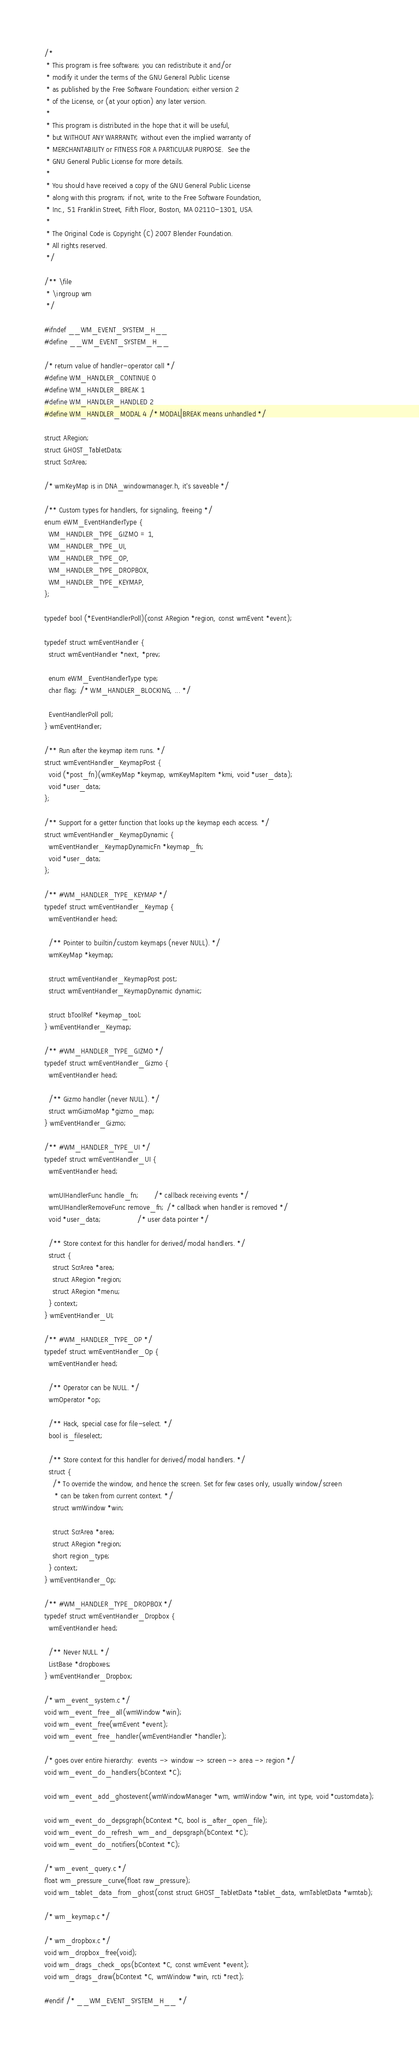<code> <loc_0><loc_0><loc_500><loc_500><_C_>/*
 * This program is free software; you can redistribute it and/or
 * modify it under the terms of the GNU General Public License
 * as published by the Free Software Foundation; either version 2
 * of the License, or (at your option) any later version.
 *
 * This program is distributed in the hope that it will be useful,
 * but WITHOUT ANY WARRANTY; without even the implied warranty of
 * MERCHANTABILITY or FITNESS FOR A PARTICULAR PURPOSE.  See the
 * GNU General Public License for more details.
 *
 * You should have received a copy of the GNU General Public License
 * along with this program; if not, write to the Free Software Foundation,
 * Inc., 51 Franklin Street, Fifth Floor, Boston, MA 02110-1301, USA.
 *
 * The Original Code is Copyright (C) 2007 Blender Foundation.
 * All rights reserved.
 */

/** \file
 * \ingroup wm
 */

#ifndef __WM_EVENT_SYSTEM_H__
#define __WM_EVENT_SYSTEM_H__

/* return value of handler-operator call */
#define WM_HANDLER_CONTINUE 0
#define WM_HANDLER_BREAK 1
#define WM_HANDLER_HANDLED 2
#define WM_HANDLER_MODAL 4 /* MODAL|BREAK means unhandled */

struct ARegion;
struct GHOST_TabletData;
struct ScrArea;

/* wmKeyMap is in DNA_windowmanager.h, it's saveable */

/** Custom types for handlers, for signaling, freeing */
enum eWM_EventHandlerType {
  WM_HANDLER_TYPE_GIZMO = 1,
  WM_HANDLER_TYPE_UI,
  WM_HANDLER_TYPE_OP,
  WM_HANDLER_TYPE_DROPBOX,
  WM_HANDLER_TYPE_KEYMAP,
};

typedef bool (*EventHandlerPoll)(const ARegion *region, const wmEvent *event);

typedef struct wmEventHandler {
  struct wmEventHandler *next, *prev;

  enum eWM_EventHandlerType type;
  char flag; /* WM_HANDLER_BLOCKING, ... */

  EventHandlerPoll poll;
} wmEventHandler;

/** Run after the keymap item runs. */
struct wmEventHandler_KeymapPost {
  void (*post_fn)(wmKeyMap *keymap, wmKeyMapItem *kmi, void *user_data);
  void *user_data;
};

/** Support for a getter function that looks up the keymap each access. */
struct wmEventHandler_KeymapDynamic {
  wmEventHandler_KeymapDynamicFn *keymap_fn;
  void *user_data;
};

/** #WM_HANDLER_TYPE_KEYMAP */
typedef struct wmEventHandler_Keymap {
  wmEventHandler head;

  /** Pointer to builtin/custom keymaps (never NULL). */
  wmKeyMap *keymap;

  struct wmEventHandler_KeymapPost post;
  struct wmEventHandler_KeymapDynamic dynamic;

  struct bToolRef *keymap_tool;
} wmEventHandler_Keymap;

/** #WM_HANDLER_TYPE_GIZMO */
typedef struct wmEventHandler_Gizmo {
  wmEventHandler head;

  /** Gizmo handler (never NULL). */
  struct wmGizmoMap *gizmo_map;
} wmEventHandler_Gizmo;

/** #WM_HANDLER_TYPE_UI */
typedef struct wmEventHandler_UI {
  wmEventHandler head;

  wmUIHandlerFunc handle_fn;       /* callback receiving events */
  wmUIHandlerRemoveFunc remove_fn; /* callback when handler is removed */
  void *user_data;                 /* user data pointer */

  /** Store context for this handler for derived/modal handlers. */
  struct {
    struct ScrArea *area;
    struct ARegion *region;
    struct ARegion *menu;
  } context;
} wmEventHandler_UI;

/** #WM_HANDLER_TYPE_OP */
typedef struct wmEventHandler_Op {
  wmEventHandler head;

  /** Operator can be NULL. */
  wmOperator *op;

  /** Hack, special case for file-select. */
  bool is_fileselect;

  /** Store context for this handler for derived/modal handlers. */
  struct {
    /* To override the window, and hence the screen. Set for few cases only, usually window/screen
     * can be taken from current context. */
    struct wmWindow *win;

    struct ScrArea *area;
    struct ARegion *region;
    short region_type;
  } context;
} wmEventHandler_Op;

/** #WM_HANDLER_TYPE_DROPBOX */
typedef struct wmEventHandler_Dropbox {
  wmEventHandler head;

  /** Never NULL. */
  ListBase *dropboxes;
} wmEventHandler_Dropbox;

/* wm_event_system.c */
void wm_event_free_all(wmWindow *win);
void wm_event_free(wmEvent *event);
void wm_event_free_handler(wmEventHandler *handler);

/* goes over entire hierarchy:  events -> window -> screen -> area -> region */
void wm_event_do_handlers(bContext *C);

void wm_event_add_ghostevent(wmWindowManager *wm, wmWindow *win, int type, void *customdata);

void wm_event_do_depsgraph(bContext *C, bool is_after_open_file);
void wm_event_do_refresh_wm_and_depsgraph(bContext *C);
void wm_event_do_notifiers(bContext *C);

/* wm_event_query.c */
float wm_pressure_curve(float raw_pressure);
void wm_tablet_data_from_ghost(const struct GHOST_TabletData *tablet_data, wmTabletData *wmtab);

/* wm_keymap.c */

/* wm_dropbox.c */
void wm_dropbox_free(void);
void wm_drags_check_ops(bContext *C, const wmEvent *event);
void wm_drags_draw(bContext *C, wmWindow *win, rcti *rect);

#endif /* __WM_EVENT_SYSTEM_H__ */
</code> 